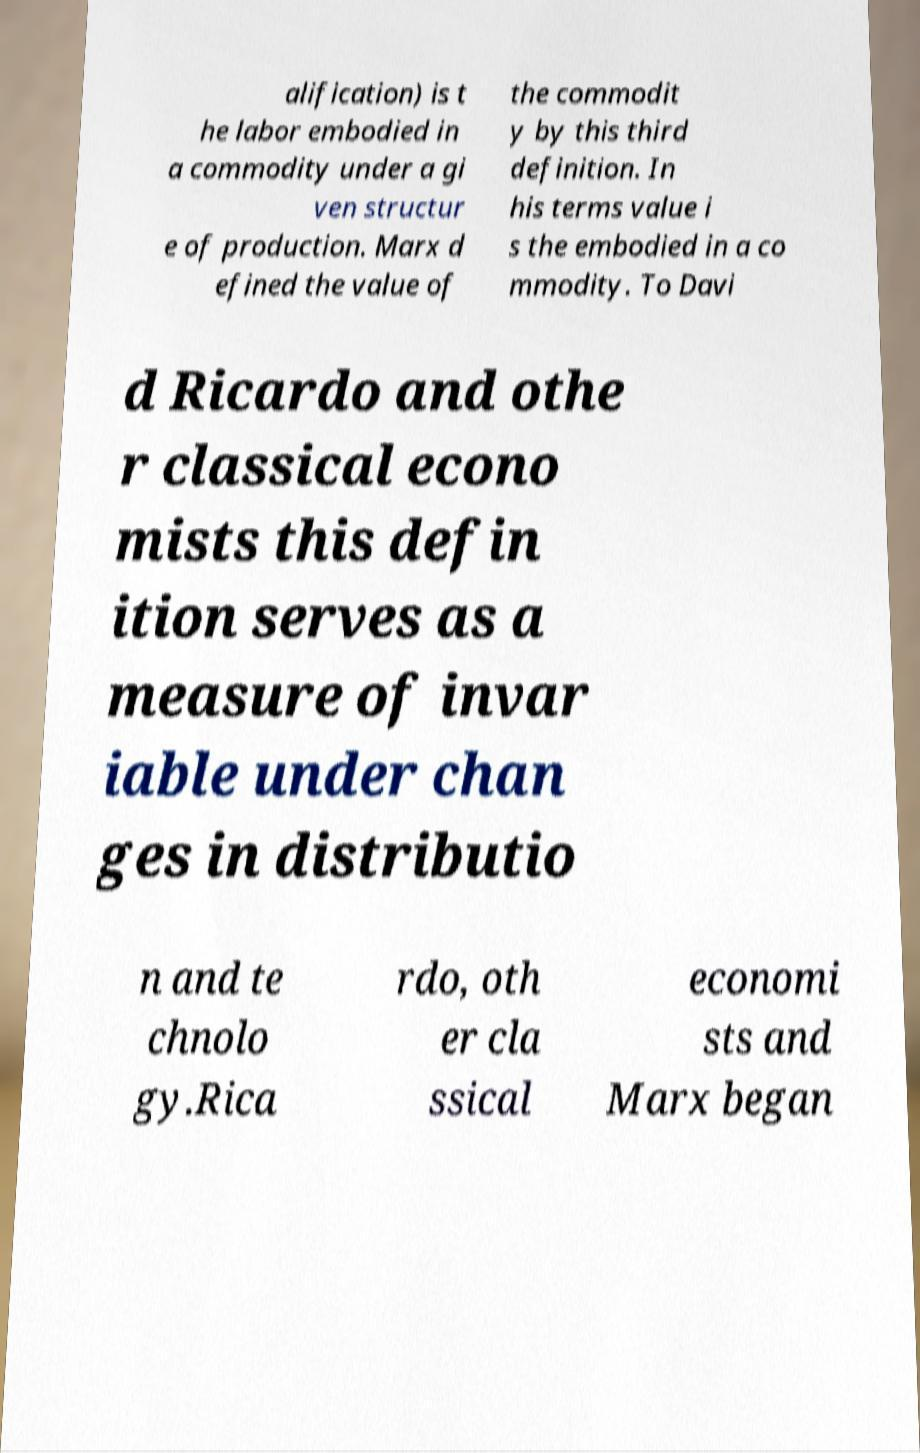I need the written content from this picture converted into text. Can you do that? alification) is t he labor embodied in a commodity under a gi ven structur e of production. Marx d efined the value of the commodit y by this third definition. In his terms value i s the embodied in a co mmodity. To Davi d Ricardo and othe r classical econo mists this defin ition serves as a measure of invar iable under chan ges in distributio n and te chnolo gy.Rica rdo, oth er cla ssical economi sts and Marx began 